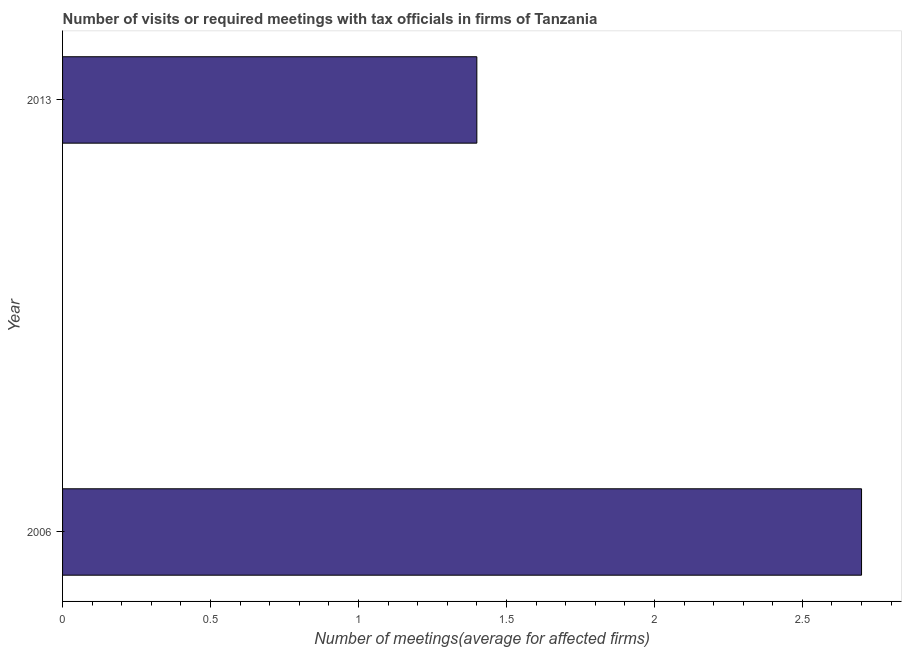Does the graph contain any zero values?
Offer a very short reply. No. What is the title of the graph?
Offer a terse response. Number of visits or required meetings with tax officials in firms of Tanzania. What is the label or title of the X-axis?
Keep it short and to the point. Number of meetings(average for affected firms). What is the label or title of the Y-axis?
Your answer should be very brief. Year. Across all years, what is the maximum number of required meetings with tax officials?
Offer a very short reply. 2.7. In which year was the number of required meetings with tax officials maximum?
Give a very brief answer. 2006. What is the sum of the number of required meetings with tax officials?
Give a very brief answer. 4.1. What is the difference between the number of required meetings with tax officials in 2006 and 2013?
Offer a terse response. 1.3. What is the average number of required meetings with tax officials per year?
Provide a succinct answer. 2.05. What is the median number of required meetings with tax officials?
Your answer should be very brief. 2.05. What is the ratio of the number of required meetings with tax officials in 2006 to that in 2013?
Your response must be concise. 1.93. Is the number of required meetings with tax officials in 2006 less than that in 2013?
Offer a terse response. No. How many years are there in the graph?
Provide a succinct answer. 2. What is the Number of meetings(average for affected firms) of 2006?
Keep it short and to the point. 2.7. What is the ratio of the Number of meetings(average for affected firms) in 2006 to that in 2013?
Your answer should be very brief. 1.93. 